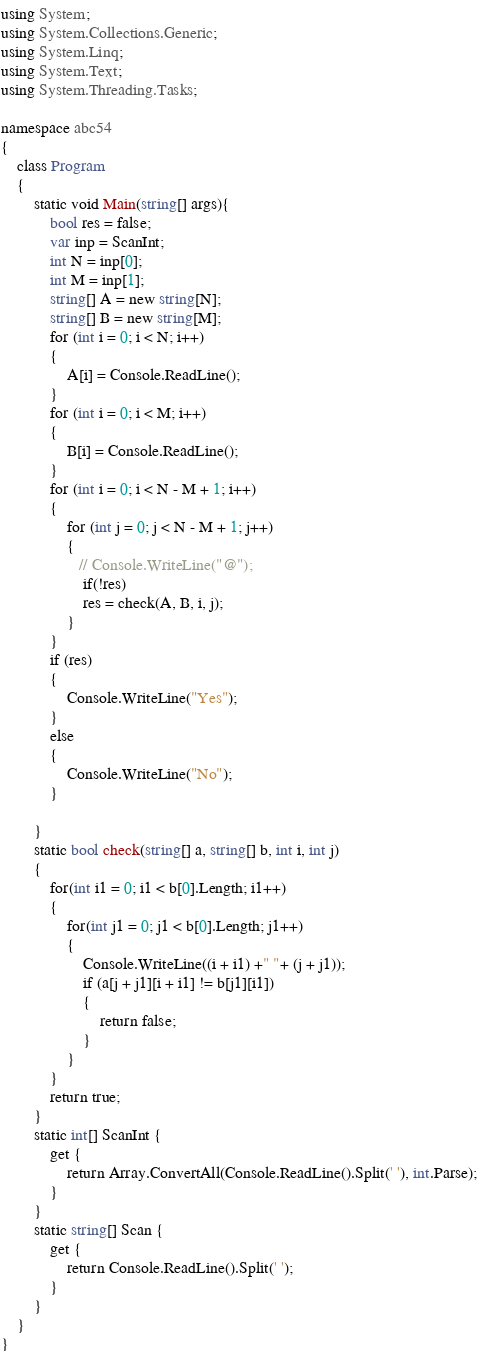<code> <loc_0><loc_0><loc_500><loc_500><_C#_>using System;
using System.Collections.Generic;
using System.Linq;
using System.Text;
using System.Threading.Tasks;

namespace abc54
{
    class Program
    {
        static void Main(string[] args){
            bool res = false;
            var inp = ScanInt;
            int N = inp[0];
            int M = inp[1];
            string[] A = new string[N];
            string[] B = new string[M];
            for (int i = 0; i < N; i++)
            {
                A[i] = Console.ReadLine();
            }
            for (int i = 0; i < M; i++)
            {
                B[i] = Console.ReadLine();
            }  
            for (int i = 0; i < N - M + 1; i++)
            {
                for (int j = 0; j < N - M + 1; j++)
                {
                   // Console.WriteLine("@");
                    if(!res)
                    res = check(A, B, i, j);
                }
            }
            if (res)
            {
                Console.WriteLine("Yes");
            }
            else
            {
                Console.WriteLine("No");
            }

        }
        static bool check(string[] a, string[] b, int i, int j)
        {
            for(int i1 = 0; i1 < b[0].Length; i1++)
            {
                for(int j1 = 0; j1 < b[0].Length; j1++)
                {
                    Console.WriteLine((i + i1) +" "+ (j + j1));
                    if (a[j + j1][i + i1] != b[j1][i1])
                    {
                        return false;
                    }
                }
            }
            return true;
        }
        static int[] ScanInt {
            get {
                return Array.ConvertAll(Console.ReadLine().Split(' '), int.Parse);
            }
        }
        static string[] Scan {
            get {
                return Console.ReadLine().Split(' ');
            }
        }
    }
}
</code> 